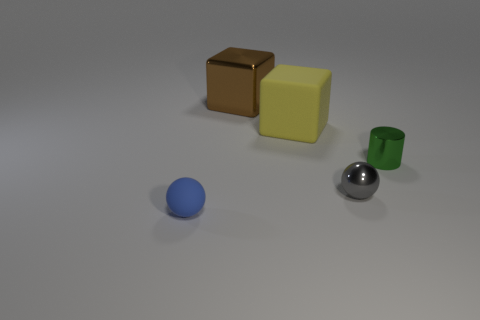Subtract all yellow spheres. Subtract all cyan blocks. How many spheres are left? 2 Subtract all yellow balls. How many brown blocks are left? 1 Add 3 tiny objects. How many blues exist? 0 Subtract all large yellow rubber cylinders. Subtract all small blue balls. How many objects are left? 4 Add 4 small green metal cylinders. How many small green metal cylinders are left? 5 Add 3 red cylinders. How many red cylinders exist? 3 Add 3 brown metallic cubes. How many objects exist? 8 Subtract all gray spheres. How many spheres are left? 1 Subtract 0 blue cubes. How many objects are left? 5 Subtract all cubes. How many objects are left? 3 